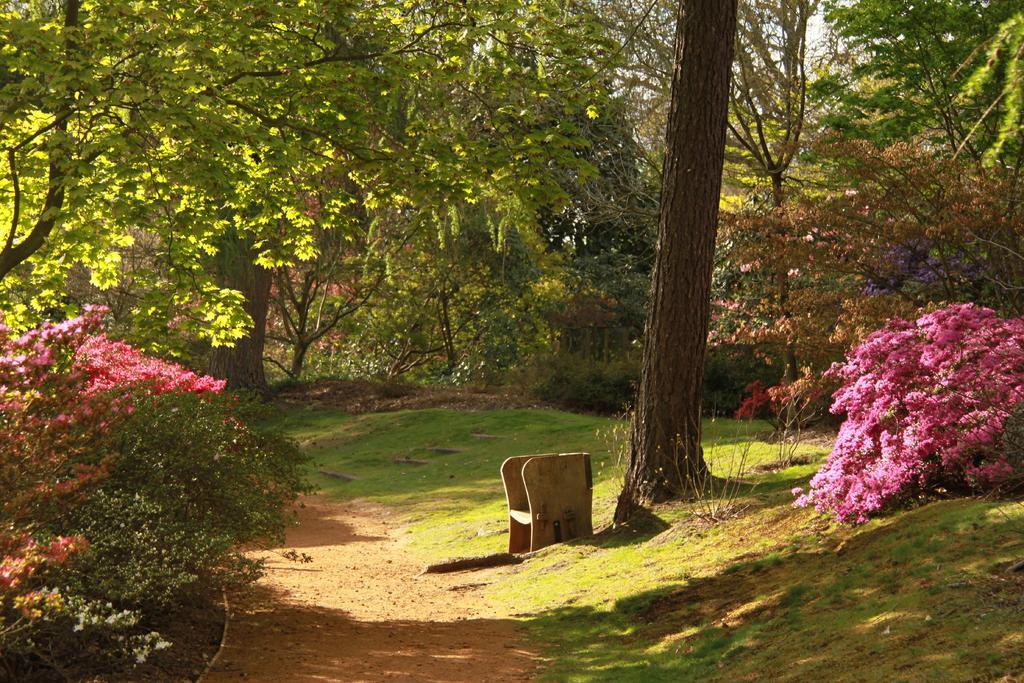Could you give a brief overview of what you see in this image? In this image there are trees and plants. We can see flowers. At the bottom there is a bench. In the background there is sky. 